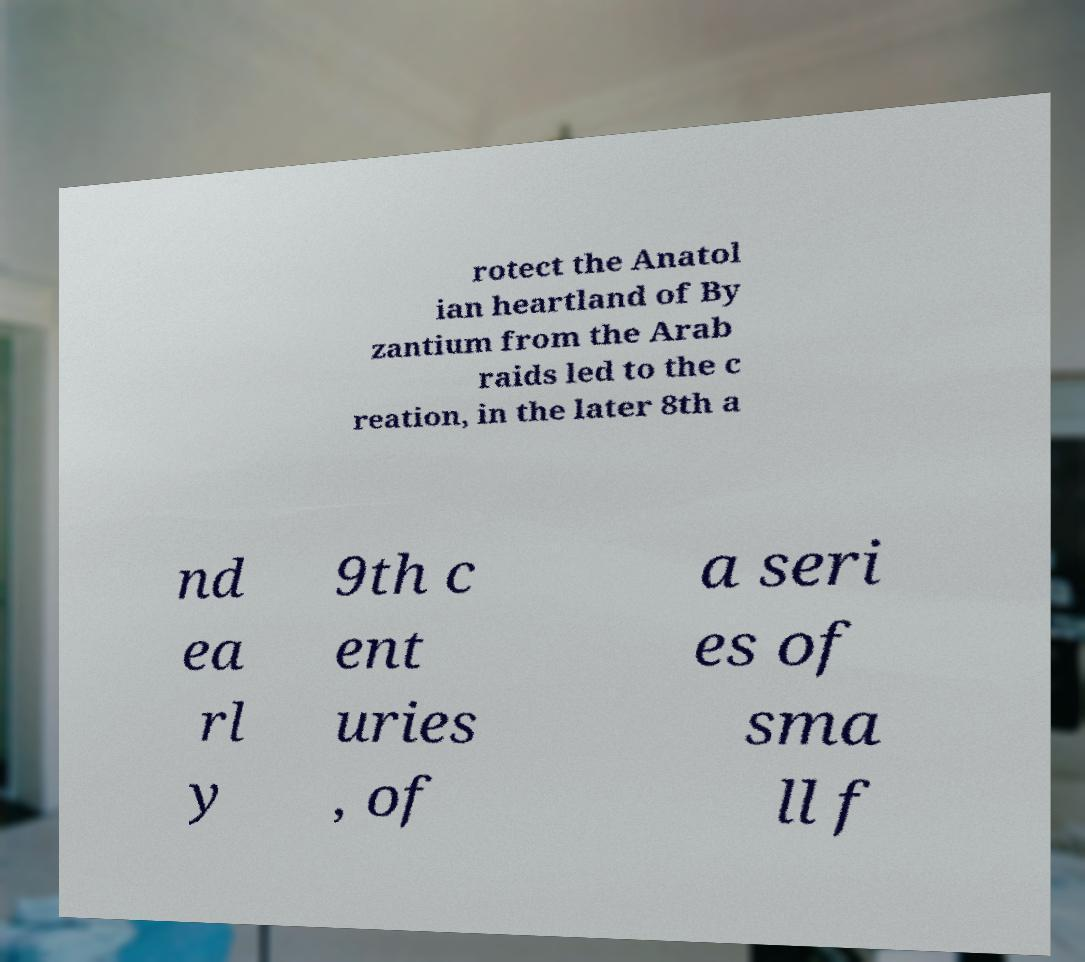Could you extract and type out the text from this image? rotect the Anatol ian heartland of By zantium from the Arab raids led to the c reation, in the later 8th a nd ea rl y 9th c ent uries , of a seri es of sma ll f 